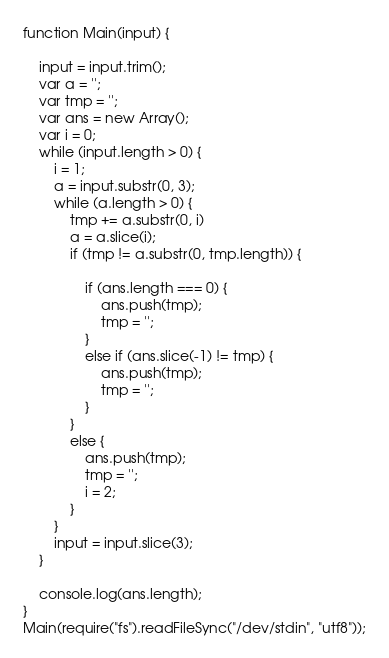<code> <loc_0><loc_0><loc_500><loc_500><_JavaScript_>function Main(input) {
 
    input = input.trim();
    var a = '';
    var tmp = '';
    var ans = new Array();
    var i = 0;
    while (input.length > 0) {
        i = 1;
        a = input.substr(0, 3);
        while (a.length > 0) {
            tmp += a.substr(0, i)
            a = a.slice(i);
            if (tmp != a.substr(0, tmp.length)) {
 
                if (ans.length === 0) {
                    ans.push(tmp);
                    tmp = '';
                }
                else if (ans.slice(-1) != tmp) {   
                    ans.push(tmp);
                    tmp = '';
                }
            }
            else {
                ans.push(tmp);
                tmp = '';
                i = 2;
            }
        }
        input = input.slice(3);
    }
 
    console.log(ans.length);
}
Main(require("fs").readFileSync("/dev/stdin", "utf8"));</code> 